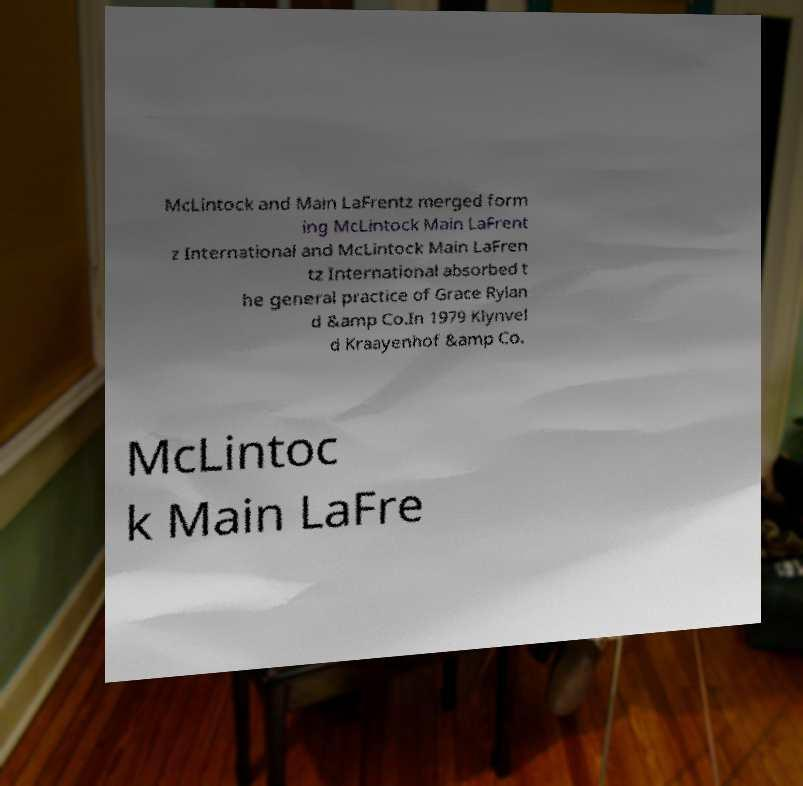For documentation purposes, I need the text within this image transcribed. Could you provide that? McLintock and Main LaFrentz merged form ing McLintock Main LaFrent z International and McLintock Main LaFren tz International absorbed t he general practice of Grace Rylan d &amp Co.In 1979 Klynvel d Kraayenhof &amp Co. McLintoc k Main LaFre 